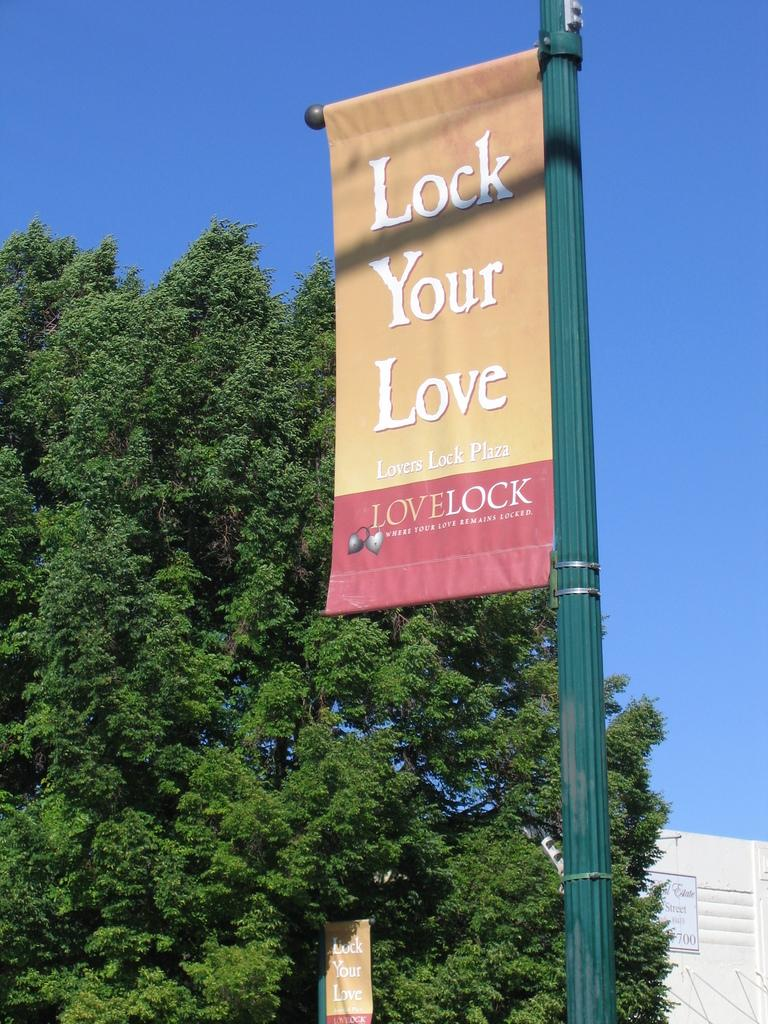What is written on the object in the image? "Lock your love" is written on the object in the image. Where is the object attached? The object is attached to a green pole. What can be seen in the background of the image? There is a tree and a building in the background of the image. What type of jeans is the person wearing in the image? There is no person wearing jeans in the image; the focus is on the object with "lock your love" written on it. What memory does the object evoke for the person who placed it there? The image does not provide any information about the person who placed the object or their memories, so we cannot answer this question. 